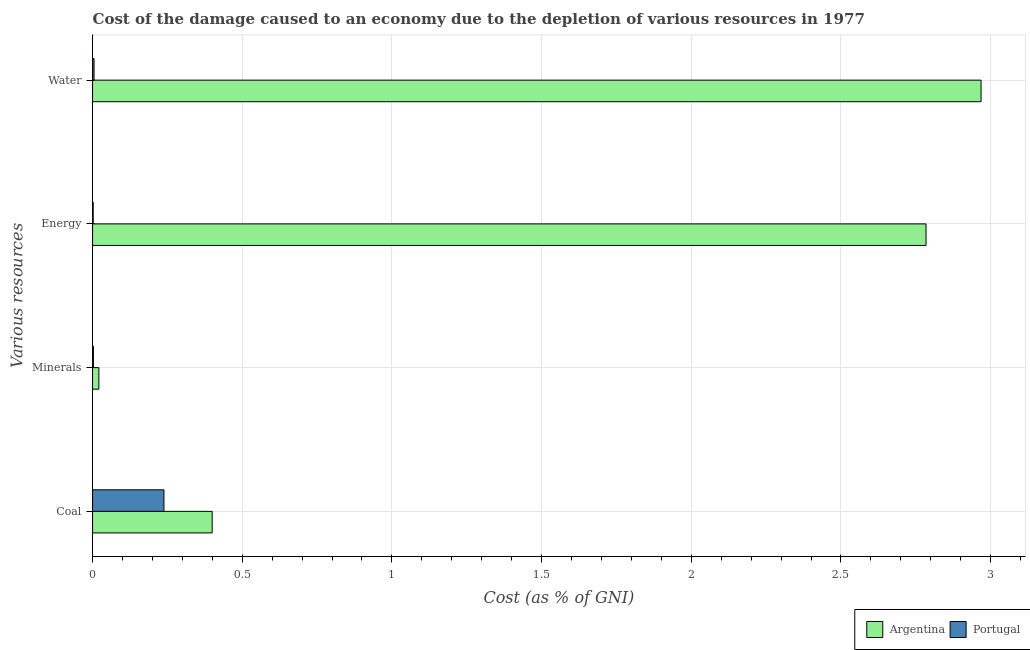How many groups of bars are there?
Your response must be concise. 4. Are the number of bars on each tick of the Y-axis equal?
Keep it short and to the point. Yes. How many bars are there on the 3rd tick from the top?
Give a very brief answer. 2. How many bars are there on the 2nd tick from the bottom?
Offer a terse response. 2. What is the label of the 3rd group of bars from the top?
Offer a very short reply. Minerals. What is the cost of damage due to depletion of water in Portugal?
Your response must be concise. 0. Across all countries, what is the maximum cost of damage due to depletion of coal?
Your response must be concise. 0.4. Across all countries, what is the minimum cost of damage due to depletion of minerals?
Ensure brevity in your answer.  0. In which country was the cost of damage due to depletion of coal minimum?
Your answer should be very brief. Portugal. What is the total cost of damage due to depletion of coal in the graph?
Offer a very short reply. 0.64. What is the difference between the cost of damage due to depletion of coal in Argentina and that in Portugal?
Ensure brevity in your answer.  0.16. What is the difference between the cost of damage due to depletion of coal in Portugal and the cost of damage due to depletion of minerals in Argentina?
Keep it short and to the point. 0.22. What is the average cost of damage due to depletion of water per country?
Offer a very short reply. 1.49. What is the difference between the cost of damage due to depletion of water and cost of damage due to depletion of coal in Portugal?
Your answer should be very brief. -0.23. What is the ratio of the cost of damage due to depletion of energy in Argentina to that in Portugal?
Your response must be concise. 1306.83. Is the difference between the cost of damage due to depletion of coal in Argentina and Portugal greater than the difference between the cost of damage due to depletion of minerals in Argentina and Portugal?
Your response must be concise. Yes. What is the difference between the highest and the second highest cost of damage due to depletion of water?
Give a very brief answer. 2.96. What is the difference between the highest and the lowest cost of damage due to depletion of minerals?
Give a very brief answer. 0.02. What does the 2nd bar from the top in Minerals represents?
Keep it short and to the point. Argentina. What does the 1st bar from the bottom in Water represents?
Offer a very short reply. Argentina. Are all the bars in the graph horizontal?
Provide a short and direct response. Yes. What is the difference between two consecutive major ticks on the X-axis?
Provide a short and direct response. 0.5. Are the values on the major ticks of X-axis written in scientific E-notation?
Keep it short and to the point. No. Does the graph contain any zero values?
Your response must be concise. No. Does the graph contain grids?
Offer a very short reply. Yes. Where does the legend appear in the graph?
Offer a terse response. Bottom right. How are the legend labels stacked?
Ensure brevity in your answer.  Horizontal. What is the title of the graph?
Provide a succinct answer. Cost of the damage caused to an economy due to the depletion of various resources in 1977 . What is the label or title of the X-axis?
Give a very brief answer. Cost (as % of GNI). What is the label or title of the Y-axis?
Ensure brevity in your answer.  Various resources. What is the Cost (as % of GNI) in Argentina in Coal?
Give a very brief answer. 0.4. What is the Cost (as % of GNI) in Portugal in Coal?
Keep it short and to the point. 0.24. What is the Cost (as % of GNI) of Argentina in Minerals?
Your response must be concise. 0.02. What is the Cost (as % of GNI) in Portugal in Minerals?
Give a very brief answer. 0. What is the Cost (as % of GNI) of Argentina in Energy?
Provide a succinct answer. 2.78. What is the Cost (as % of GNI) of Portugal in Energy?
Offer a very short reply. 0. What is the Cost (as % of GNI) of Argentina in Water?
Keep it short and to the point. 2.97. What is the Cost (as % of GNI) of Portugal in Water?
Your answer should be very brief. 0. Across all Various resources, what is the maximum Cost (as % of GNI) of Argentina?
Offer a terse response. 2.97. Across all Various resources, what is the maximum Cost (as % of GNI) of Portugal?
Keep it short and to the point. 0.24. Across all Various resources, what is the minimum Cost (as % of GNI) of Argentina?
Your answer should be compact. 0.02. Across all Various resources, what is the minimum Cost (as % of GNI) in Portugal?
Provide a succinct answer. 0. What is the total Cost (as % of GNI) in Argentina in the graph?
Provide a short and direct response. 6.17. What is the total Cost (as % of GNI) in Portugal in the graph?
Offer a terse response. 0.25. What is the difference between the Cost (as % of GNI) of Argentina in Coal and that in Minerals?
Provide a succinct answer. 0.38. What is the difference between the Cost (as % of GNI) in Portugal in Coal and that in Minerals?
Make the answer very short. 0.24. What is the difference between the Cost (as % of GNI) of Argentina in Coal and that in Energy?
Your answer should be compact. -2.38. What is the difference between the Cost (as % of GNI) of Portugal in Coal and that in Energy?
Provide a succinct answer. 0.24. What is the difference between the Cost (as % of GNI) in Argentina in Coal and that in Water?
Keep it short and to the point. -2.57. What is the difference between the Cost (as % of GNI) of Portugal in Coal and that in Water?
Your answer should be very brief. 0.23. What is the difference between the Cost (as % of GNI) in Argentina in Minerals and that in Energy?
Your response must be concise. -2.76. What is the difference between the Cost (as % of GNI) of Portugal in Minerals and that in Energy?
Give a very brief answer. 0. What is the difference between the Cost (as % of GNI) of Argentina in Minerals and that in Water?
Your answer should be compact. -2.95. What is the difference between the Cost (as % of GNI) in Portugal in Minerals and that in Water?
Your answer should be compact. -0. What is the difference between the Cost (as % of GNI) in Argentina in Energy and that in Water?
Keep it short and to the point. -0.18. What is the difference between the Cost (as % of GNI) of Portugal in Energy and that in Water?
Your response must be concise. -0. What is the difference between the Cost (as % of GNI) in Argentina in Coal and the Cost (as % of GNI) in Portugal in Minerals?
Provide a succinct answer. 0.4. What is the difference between the Cost (as % of GNI) in Argentina in Coal and the Cost (as % of GNI) in Portugal in Energy?
Keep it short and to the point. 0.4. What is the difference between the Cost (as % of GNI) of Argentina in Coal and the Cost (as % of GNI) of Portugal in Water?
Give a very brief answer. 0.39. What is the difference between the Cost (as % of GNI) of Argentina in Minerals and the Cost (as % of GNI) of Portugal in Energy?
Your answer should be very brief. 0.02. What is the difference between the Cost (as % of GNI) of Argentina in Minerals and the Cost (as % of GNI) of Portugal in Water?
Your answer should be compact. 0.02. What is the difference between the Cost (as % of GNI) of Argentina in Energy and the Cost (as % of GNI) of Portugal in Water?
Offer a terse response. 2.78. What is the average Cost (as % of GNI) of Argentina per Various resources?
Ensure brevity in your answer.  1.54. What is the average Cost (as % of GNI) of Portugal per Various resources?
Provide a short and direct response. 0.06. What is the difference between the Cost (as % of GNI) in Argentina and Cost (as % of GNI) in Portugal in Coal?
Your answer should be compact. 0.16. What is the difference between the Cost (as % of GNI) in Argentina and Cost (as % of GNI) in Portugal in Minerals?
Give a very brief answer. 0.02. What is the difference between the Cost (as % of GNI) in Argentina and Cost (as % of GNI) in Portugal in Energy?
Give a very brief answer. 2.78. What is the difference between the Cost (as % of GNI) of Argentina and Cost (as % of GNI) of Portugal in Water?
Give a very brief answer. 2.96. What is the ratio of the Cost (as % of GNI) of Argentina in Coal to that in Minerals?
Your response must be concise. 19.01. What is the ratio of the Cost (as % of GNI) in Portugal in Coal to that in Minerals?
Ensure brevity in your answer.  85.05. What is the ratio of the Cost (as % of GNI) in Argentina in Coal to that in Energy?
Give a very brief answer. 0.14. What is the ratio of the Cost (as % of GNI) in Portugal in Coal to that in Energy?
Offer a terse response. 111.91. What is the ratio of the Cost (as % of GNI) of Argentina in Coal to that in Water?
Make the answer very short. 0.13. What is the ratio of the Cost (as % of GNI) in Portugal in Coal to that in Water?
Ensure brevity in your answer.  48.32. What is the ratio of the Cost (as % of GNI) of Argentina in Minerals to that in Energy?
Ensure brevity in your answer.  0.01. What is the ratio of the Cost (as % of GNI) in Portugal in Minerals to that in Energy?
Provide a succinct answer. 1.32. What is the ratio of the Cost (as % of GNI) in Argentina in Minerals to that in Water?
Your response must be concise. 0.01. What is the ratio of the Cost (as % of GNI) of Portugal in Minerals to that in Water?
Your answer should be compact. 0.57. What is the ratio of the Cost (as % of GNI) of Argentina in Energy to that in Water?
Your response must be concise. 0.94. What is the ratio of the Cost (as % of GNI) in Portugal in Energy to that in Water?
Your response must be concise. 0.43. What is the difference between the highest and the second highest Cost (as % of GNI) of Argentina?
Your answer should be compact. 0.18. What is the difference between the highest and the second highest Cost (as % of GNI) in Portugal?
Make the answer very short. 0.23. What is the difference between the highest and the lowest Cost (as % of GNI) of Argentina?
Offer a terse response. 2.95. What is the difference between the highest and the lowest Cost (as % of GNI) in Portugal?
Your answer should be compact. 0.24. 